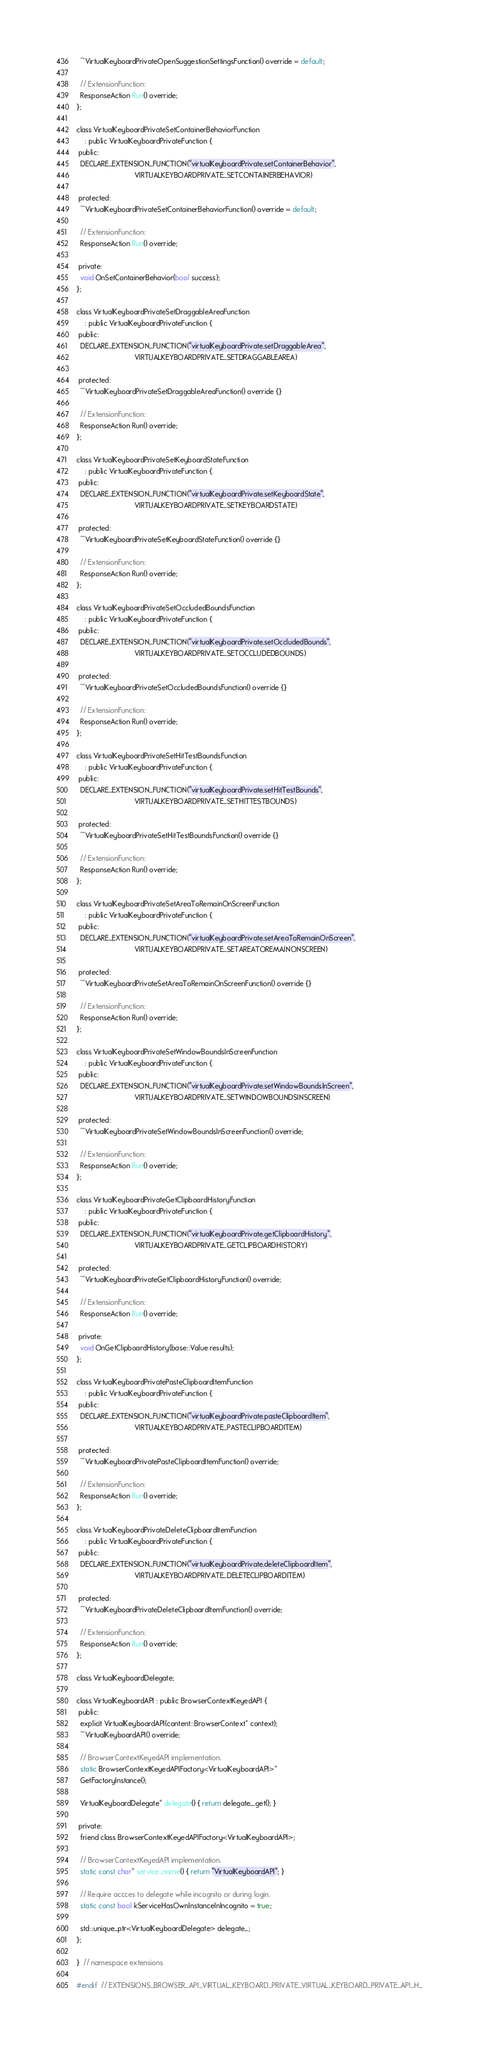Convert code to text. <code><loc_0><loc_0><loc_500><loc_500><_C_>  ~VirtualKeyboardPrivateOpenSuggestionSettingsFunction() override = default;

  // ExtensionFunction:
  ResponseAction Run() override;
};

class VirtualKeyboardPrivateSetContainerBehaviorFunction
    : public VirtualKeyboardPrivateFunction {
 public:
  DECLARE_EXTENSION_FUNCTION("virtualKeyboardPrivate.setContainerBehavior",
                             VIRTUALKEYBOARDPRIVATE_SETCONTAINERBEHAVIOR)

 protected:
  ~VirtualKeyboardPrivateSetContainerBehaviorFunction() override = default;

  // ExtensionFunction:
  ResponseAction Run() override;

 private:
  void OnSetContainerBehavior(bool success);
};

class VirtualKeyboardPrivateSetDraggableAreaFunction
    : public VirtualKeyboardPrivateFunction {
 public:
  DECLARE_EXTENSION_FUNCTION("virtualKeyboardPrivate.setDraggableArea",
                             VIRTUALKEYBOARDPRIVATE_SETDRAGGABLEAREA)

 protected:
  ~VirtualKeyboardPrivateSetDraggableAreaFunction() override {}

  // ExtensionFunction:
  ResponseAction Run() override;
};

class VirtualKeyboardPrivateSetKeyboardStateFunction
    : public VirtualKeyboardPrivateFunction {
 public:
  DECLARE_EXTENSION_FUNCTION("virtualKeyboardPrivate.setKeyboardState",
                             VIRTUALKEYBOARDPRIVATE_SETKEYBOARDSTATE)

 protected:
  ~VirtualKeyboardPrivateSetKeyboardStateFunction() override {}

  // ExtensionFunction:
  ResponseAction Run() override;
};

class VirtualKeyboardPrivateSetOccludedBoundsFunction
    : public VirtualKeyboardPrivateFunction {
 public:
  DECLARE_EXTENSION_FUNCTION("virtualKeyboardPrivate.setOccludedBounds",
                             VIRTUALKEYBOARDPRIVATE_SETOCCLUDEDBOUNDS)

 protected:
  ~VirtualKeyboardPrivateSetOccludedBoundsFunction() override {}

  // ExtensionFunction:
  ResponseAction Run() override;
};

class VirtualKeyboardPrivateSetHitTestBoundsFunction
    : public VirtualKeyboardPrivateFunction {
 public:
  DECLARE_EXTENSION_FUNCTION("virtualKeyboardPrivate.setHitTestBounds",
                             VIRTUALKEYBOARDPRIVATE_SETHITTESTBOUNDS)

 protected:
  ~VirtualKeyboardPrivateSetHitTestBoundsFunction() override {}

  // ExtensionFunction:
  ResponseAction Run() override;
};

class VirtualKeyboardPrivateSetAreaToRemainOnScreenFunction
    : public VirtualKeyboardPrivateFunction {
 public:
  DECLARE_EXTENSION_FUNCTION("virtualKeyboardPrivate.setAreaToRemainOnScreen",
                             VIRTUALKEYBOARDPRIVATE_SETAREATOREMAINONSCREEN)

 protected:
  ~VirtualKeyboardPrivateSetAreaToRemainOnScreenFunction() override {}

  // ExtensionFunction:
  ResponseAction Run() override;
};

class VirtualKeyboardPrivateSetWindowBoundsInScreenFunction
    : public VirtualKeyboardPrivateFunction {
 public:
  DECLARE_EXTENSION_FUNCTION("virtualKeyboardPrivate.setWindowBoundsInScreen",
                             VIRTUALKEYBOARDPRIVATE_SETWINDOWBOUNDSINSCREEN)

 protected:
  ~VirtualKeyboardPrivateSetWindowBoundsInScreenFunction() override;

  // ExtensionFunction:
  ResponseAction Run() override;
};

class VirtualKeyboardPrivateGetClipboardHistoryFunction
    : public VirtualKeyboardPrivateFunction {
 public:
  DECLARE_EXTENSION_FUNCTION("virtualKeyboardPrivate.getClipboardHistory",
                             VIRTUALKEYBOARDPRIVATE_GETCLIPBOARDHISTORY)

 protected:
  ~VirtualKeyboardPrivateGetClipboardHistoryFunction() override;

  // ExtensionFunction:
  ResponseAction Run() override;

 private:
  void OnGetClipboardHistory(base::Value results);
};

class VirtualKeyboardPrivatePasteClipboardItemFunction
    : public VirtualKeyboardPrivateFunction {
 public:
  DECLARE_EXTENSION_FUNCTION("virtualKeyboardPrivate.pasteClipboardItem",
                             VIRTUALKEYBOARDPRIVATE_PASTECLIPBOARDITEM)

 protected:
  ~VirtualKeyboardPrivatePasteClipboardItemFunction() override;

  // ExtensionFunction:
  ResponseAction Run() override;
};

class VirtualKeyboardPrivateDeleteClipboardItemFunction
    : public VirtualKeyboardPrivateFunction {
 public:
  DECLARE_EXTENSION_FUNCTION("virtualKeyboardPrivate.deleteClipboardItem",
                             VIRTUALKEYBOARDPRIVATE_DELETECLIPBOARDITEM)

 protected:
  ~VirtualKeyboardPrivateDeleteClipboardItemFunction() override;

  // ExtensionFunction:
  ResponseAction Run() override;
};

class VirtualKeyboardDelegate;

class VirtualKeyboardAPI : public BrowserContextKeyedAPI {
 public:
  explicit VirtualKeyboardAPI(content::BrowserContext* context);
  ~VirtualKeyboardAPI() override;

  // BrowserContextKeyedAPI implementation.
  static BrowserContextKeyedAPIFactory<VirtualKeyboardAPI>*
  GetFactoryInstance();

  VirtualKeyboardDelegate* delegate() { return delegate_.get(); }

 private:
  friend class BrowserContextKeyedAPIFactory<VirtualKeyboardAPI>;

  // BrowserContextKeyedAPI implementation.
  static const char* service_name() { return "VirtualKeyboardAPI"; }

  // Require accces to delegate while incognito or during login.
  static const bool kServiceHasOwnInstanceInIncognito = true;

  std::unique_ptr<VirtualKeyboardDelegate> delegate_;
};

}  // namespace extensions

#endif  // EXTENSIONS_BROWSER_API_VIRTUAL_KEYBOARD_PRIVATE_VIRTUAL_KEYBOARD_PRIVATE_API_H_
</code> 